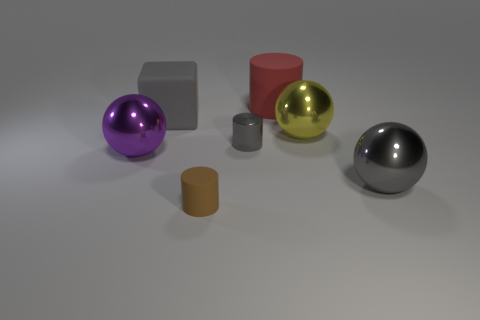Subtract all small brown matte cylinders. How many cylinders are left? 2 Add 2 big yellow things. How many objects exist? 9 Subtract 1 cylinders. How many cylinders are left? 2 Subtract all blocks. How many objects are left? 6 Subtract all yellow spheres. How many spheres are left? 2 Subtract 0 blue balls. How many objects are left? 7 Subtract all brown spheres. Subtract all gray blocks. How many spheres are left? 3 Subtract all small purple things. Subtract all small objects. How many objects are left? 5 Add 1 big balls. How many big balls are left? 4 Add 1 large green shiny objects. How many large green shiny objects exist? 1 